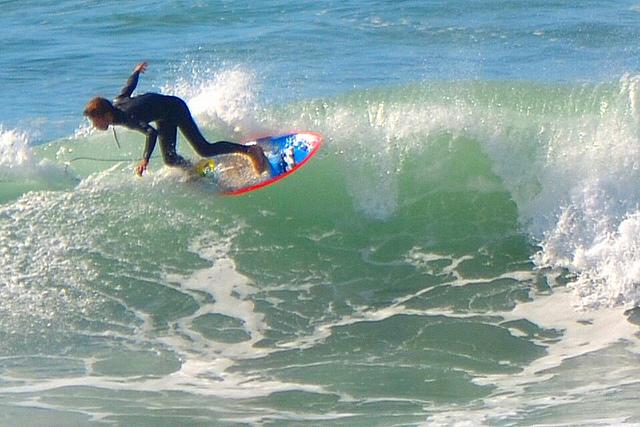Is this person a surfer?
Give a very brief answer. Yes. Does this person have anything connecting him to his board?
Write a very short answer. Yes. What color is the water?
Answer briefly. Green. 